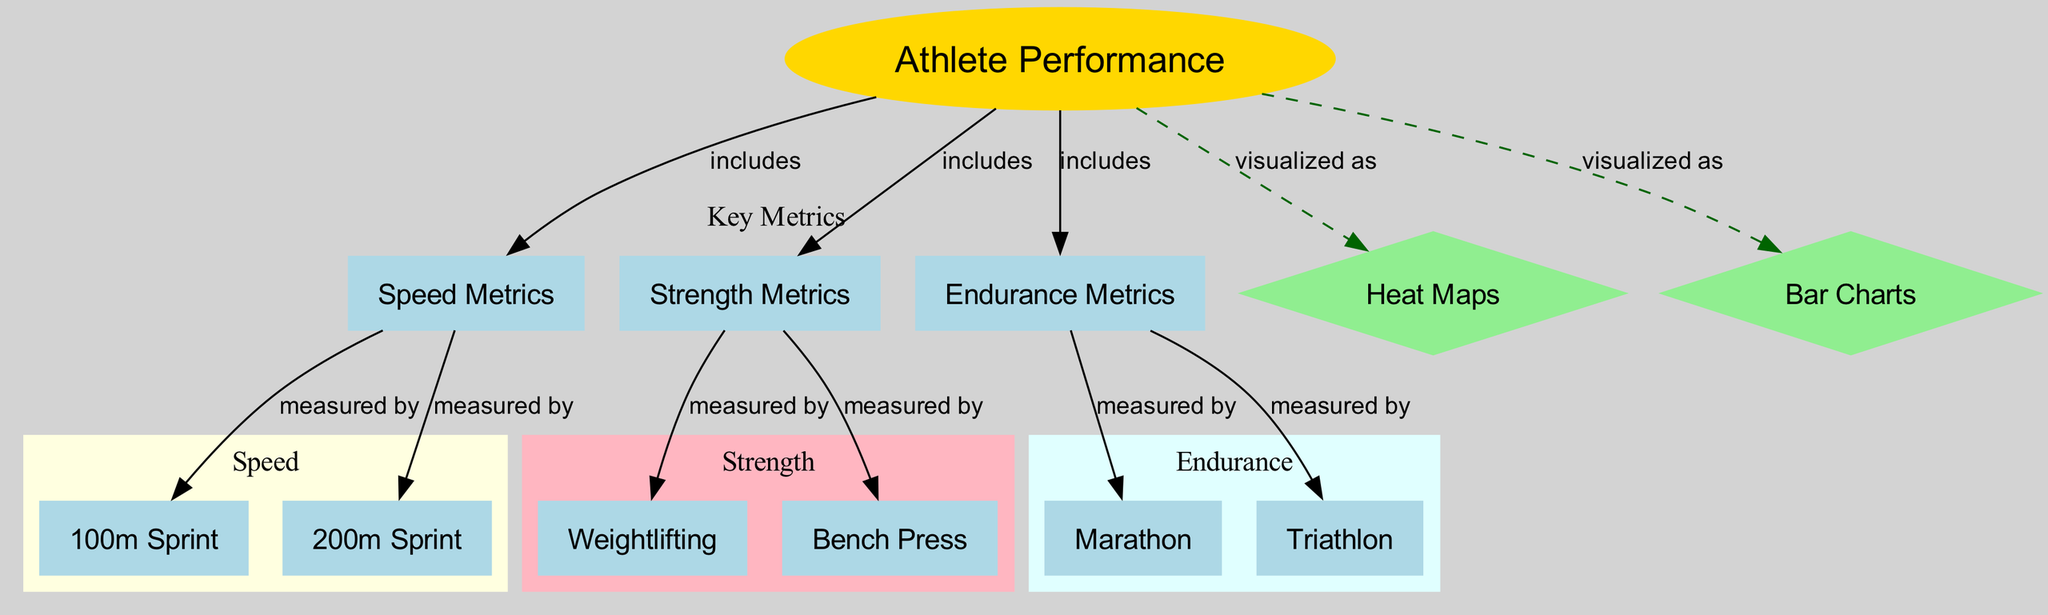What is the main topic of the diagram? The diagram's title is "Athlete Performance Analysis," indicating that the focus is on how various metrics relate to the performance of athletes.
Answer: Athlete Performance Analysis How many key metrics are included in the diagram? The diagram includes three key metrics: Speed, Strength, and Endurance, which are visually grouped together.
Answer: Three What type of chart is used to visualize athlete performance? The diagram specifies that athlete performance is visualized as Heat Maps and Bar Charts.
Answer: Heat Maps and Bar Charts Which metric measures the 100m sprint? The 100m sprint is classified under Speed Metrics, showing that it pertains to measuring speed performance.
Answer: Speed Metrics What are the two types of endurance metrics mentioned in the diagram? The endurance metrics specified in the diagram include Marathon and Triathlon, clearly showing the endurance-focused events.
Answer: Marathon and Triathlon How are Strength Metrics connected to Weightlifting? Strength Metrics includes Weightlifting, indicating that Weightlifting is a specific measurement used to assess strength.
Answer: Measured by Which metric includes the Bench Press? Strength Metrics includes the Bench Press, classifying it under strength performance measures.
Answer: Strength Metrics What visual tools are used to represent data in the diagram? The diagram specifies that performance data is visualized as both Heat Maps and Bar Charts, indicating a dual representation.
Answer: Heat Maps and Bar Charts What is the relationship between Athlete Performance and Endurance Metrics? Athlete Performance includes Endurance Metrics, meaning that endurance is a crucial component of overall athlete performance analysis.
Answer: Includes 